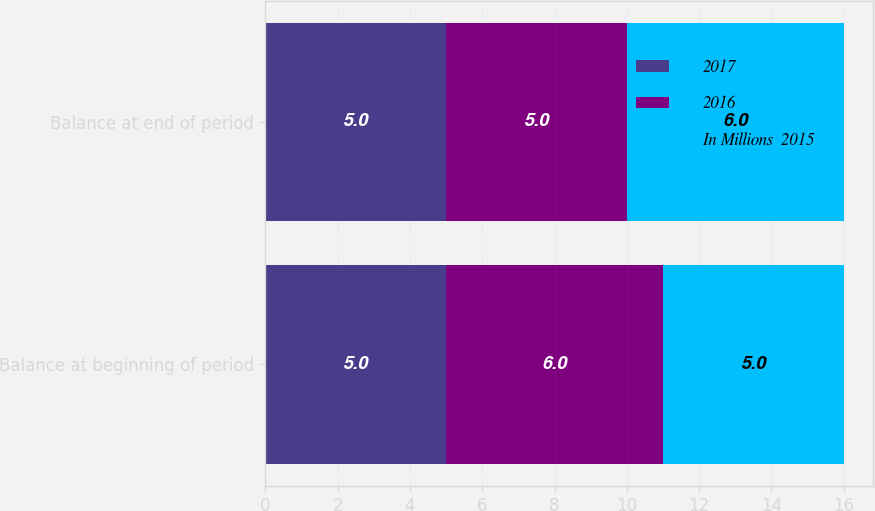<chart> <loc_0><loc_0><loc_500><loc_500><stacked_bar_chart><ecel><fcel>Balance at beginning of period<fcel>Balance at end of period<nl><fcel>2017<fcel>5<fcel>5<nl><fcel>2016<fcel>6<fcel>5<nl><fcel>In Millions  2015<fcel>5<fcel>6<nl></chart> 